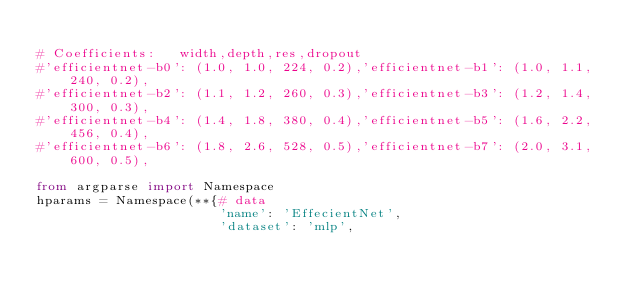<code> <loc_0><loc_0><loc_500><loc_500><_Python_>
# Coefficients:   width,depth,res,dropout
#'efficientnet-b0': (1.0, 1.0, 224, 0.2),'efficientnet-b1': (1.0, 1.1, 240, 0.2),
#'efficientnet-b2': (1.1, 1.2, 260, 0.3),'efficientnet-b3': (1.2, 1.4, 300, 0.3),
#'efficientnet-b4': (1.4, 1.8, 380, 0.4),'efficientnet-b5': (1.6, 2.2, 456, 0.4),
#'efficientnet-b6': (1.8, 2.6, 528, 0.5),'efficientnet-b7': (2.0, 3.1, 600, 0.5),

from argparse import Namespace
hparams = Namespace(**{# data
                       'name': 'EffecientNet',
                       'dataset': 'mlp',</code> 